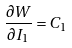<formula> <loc_0><loc_0><loc_500><loc_500>\frac { \partial W } { \partial I _ { 1 } } = C _ { 1 }</formula> 